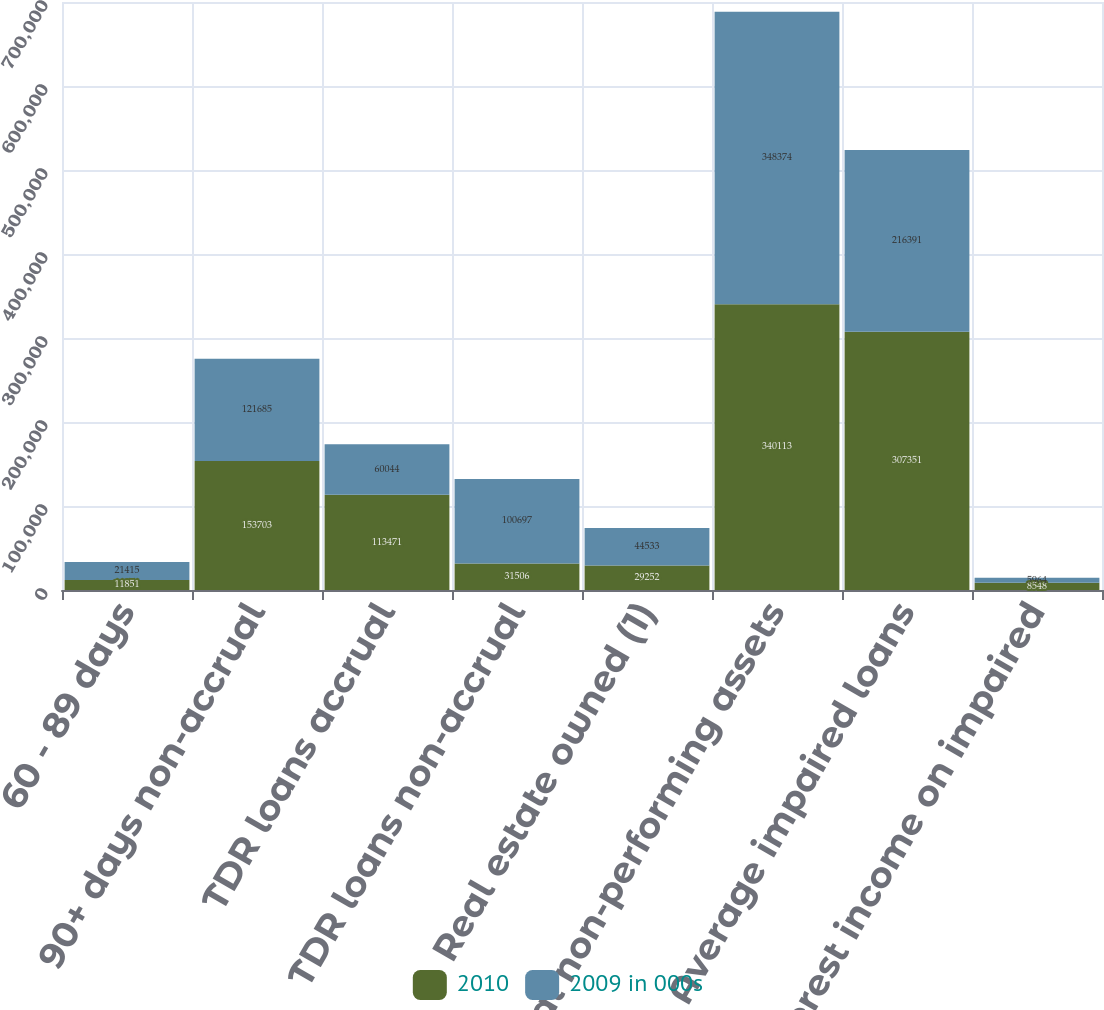Convert chart to OTSL. <chart><loc_0><loc_0><loc_500><loc_500><stacked_bar_chart><ecel><fcel>60 - 89 days<fcel>90+ days non-accrual<fcel>TDR loans accrual<fcel>TDR loans non-accrual<fcel>Real estate owned (1)<fcel>Total non-performing assets<fcel>Average impaired loans<fcel>Interest income on impaired<nl><fcel>2010<fcel>11851<fcel>153703<fcel>113471<fcel>31506<fcel>29252<fcel>340113<fcel>307351<fcel>8548<nl><fcel>2009 in 000s<fcel>21415<fcel>121685<fcel>60044<fcel>100697<fcel>44533<fcel>348374<fcel>216391<fcel>5964<nl></chart> 